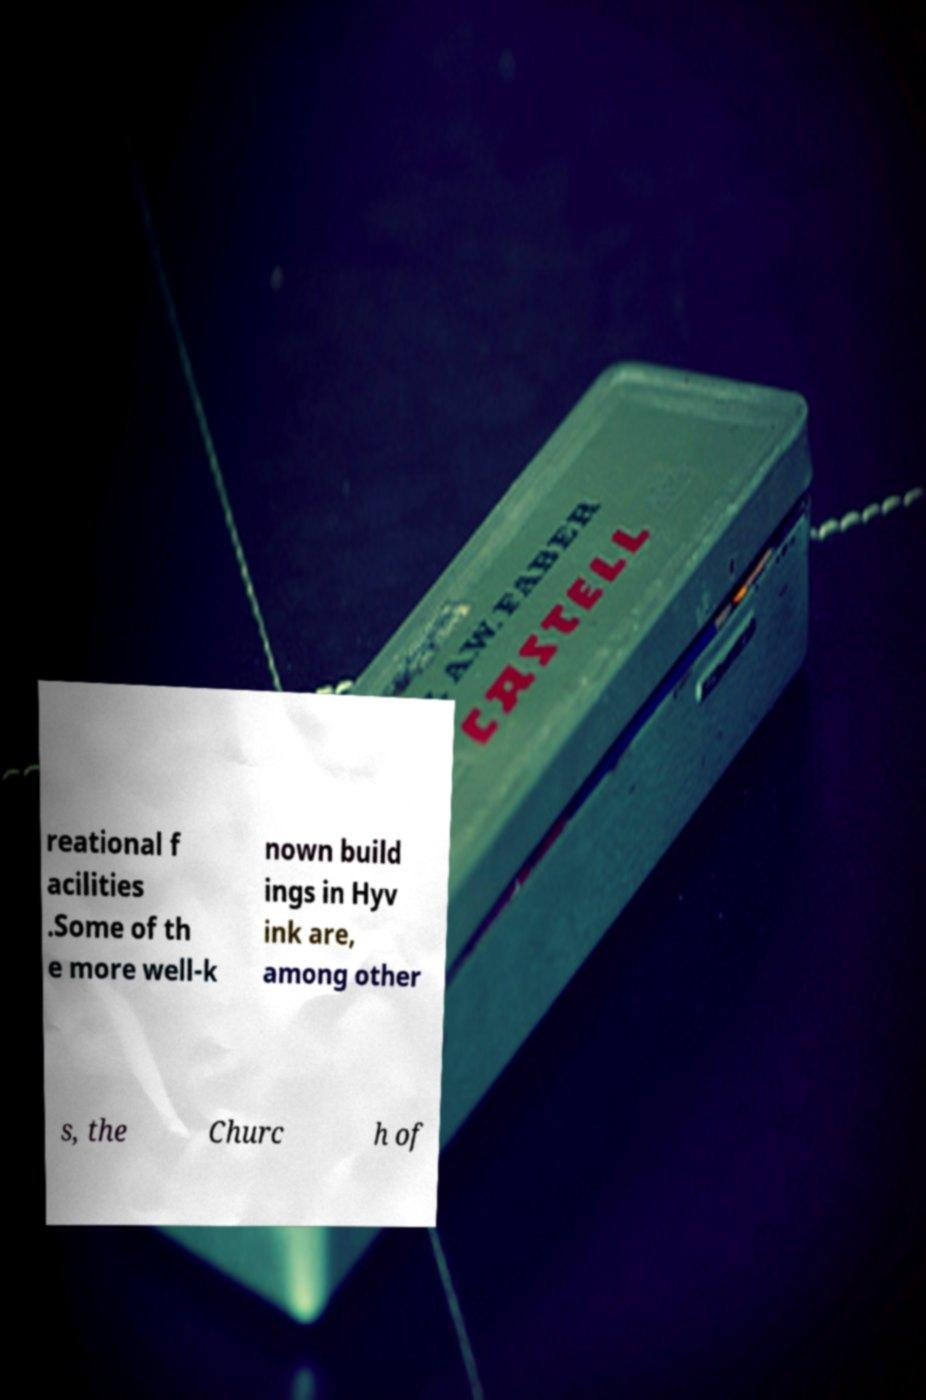For documentation purposes, I need the text within this image transcribed. Could you provide that? reational f acilities .Some of th e more well-k nown build ings in Hyv ink are, among other s, the Churc h of 